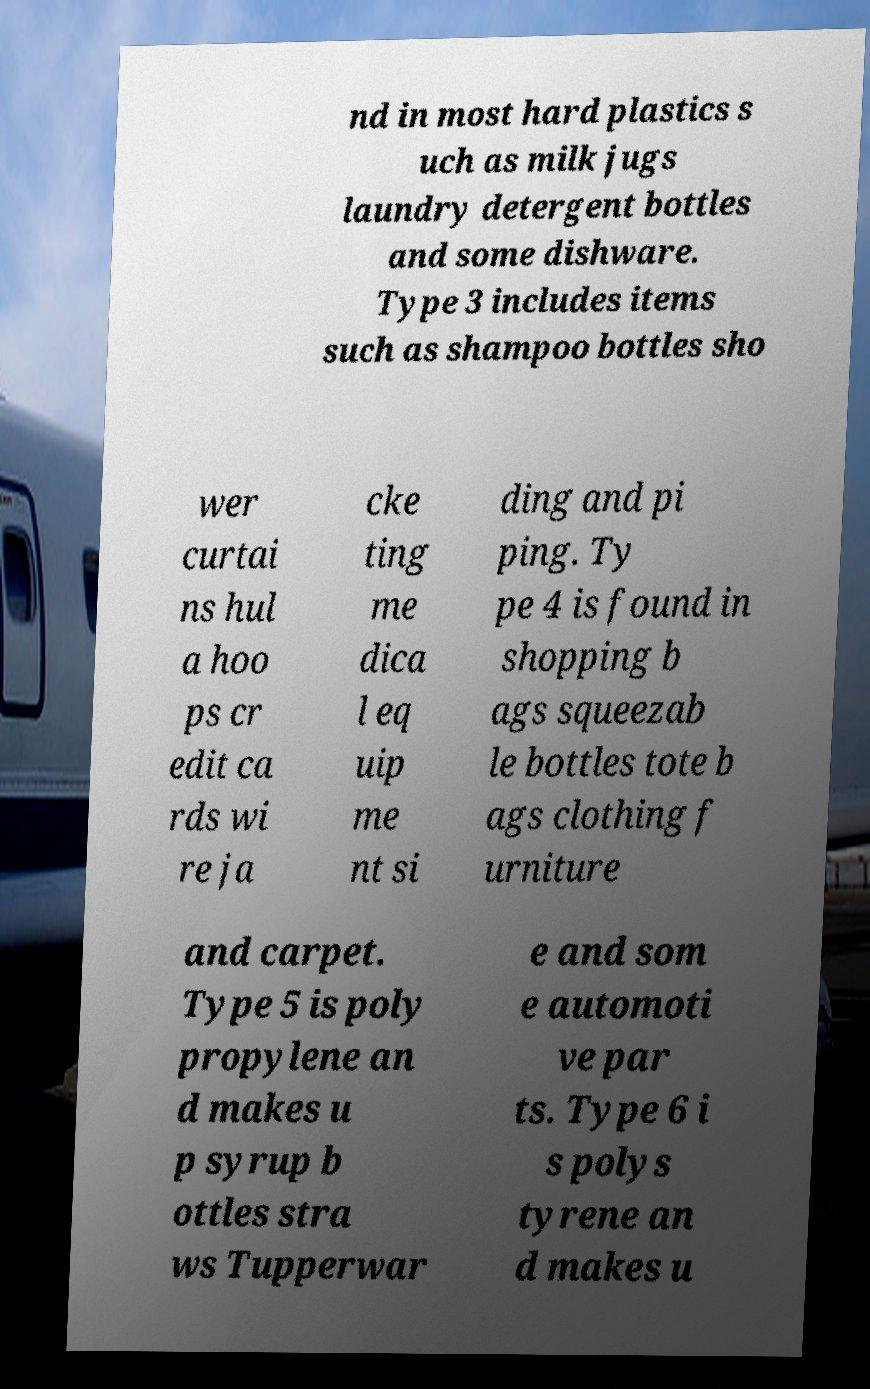Could you assist in decoding the text presented in this image and type it out clearly? nd in most hard plastics s uch as milk jugs laundry detergent bottles and some dishware. Type 3 includes items such as shampoo bottles sho wer curtai ns hul a hoo ps cr edit ca rds wi re ja cke ting me dica l eq uip me nt si ding and pi ping. Ty pe 4 is found in shopping b ags squeezab le bottles tote b ags clothing f urniture and carpet. Type 5 is poly propylene an d makes u p syrup b ottles stra ws Tupperwar e and som e automoti ve par ts. Type 6 i s polys tyrene an d makes u 